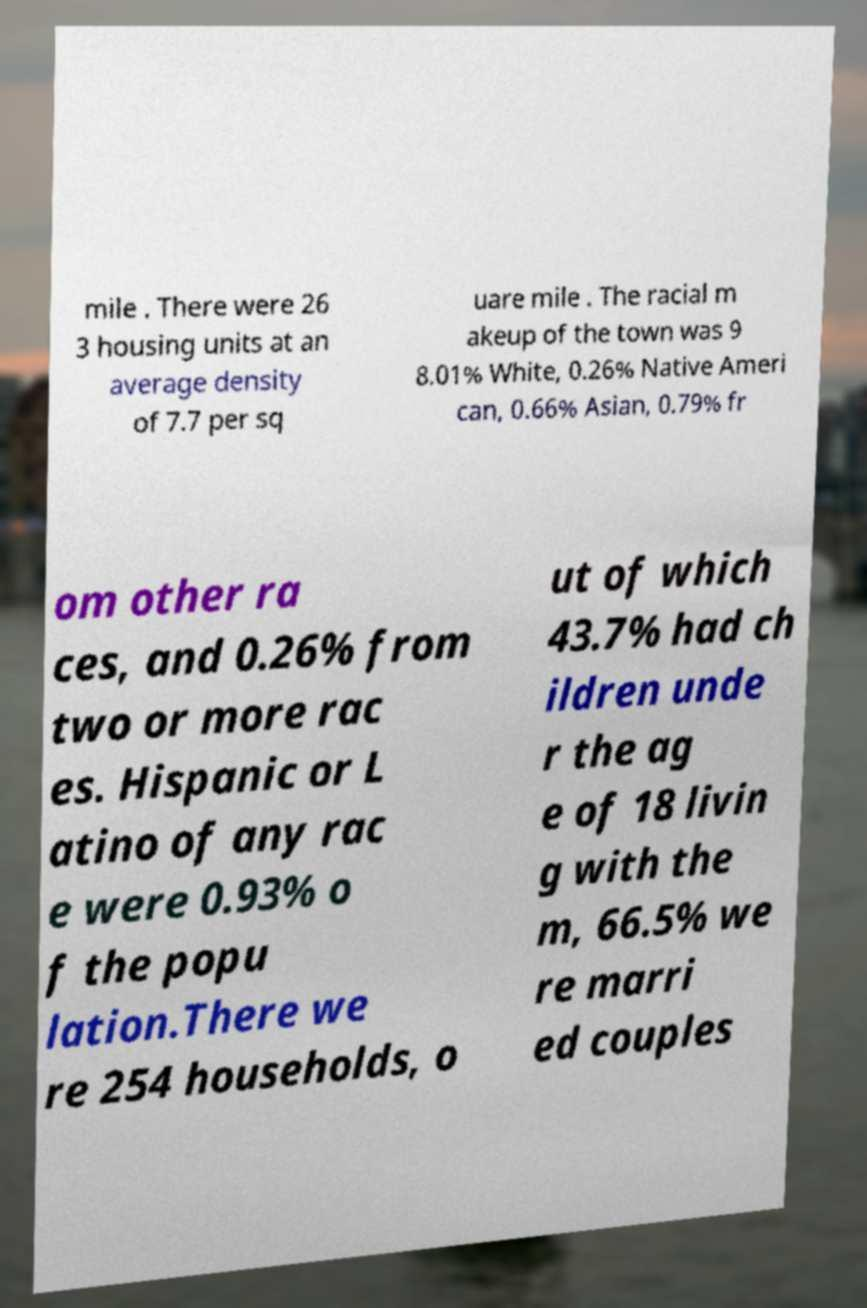I need the written content from this picture converted into text. Can you do that? mile . There were 26 3 housing units at an average density of 7.7 per sq uare mile . The racial m akeup of the town was 9 8.01% White, 0.26% Native Ameri can, 0.66% Asian, 0.79% fr om other ra ces, and 0.26% from two or more rac es. Hispanic or L atino of any rac e were 0.93% o f the popu lation.There we re 254 households, o ut of which 43.7% had ch ildren unde r the ag e of 18 livin g with the m, 66.5% we re marri ed couples 